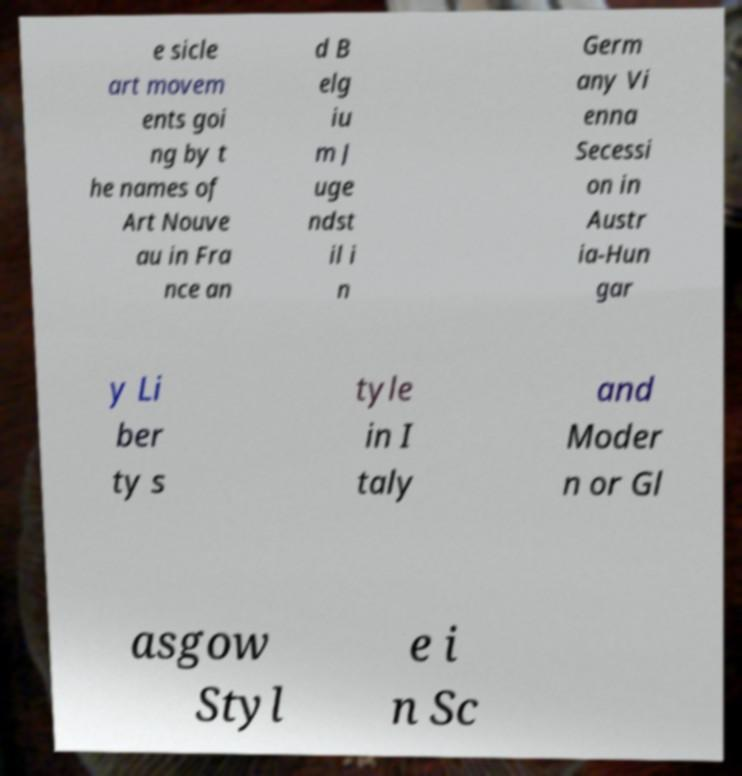Could you extract and type out the text from this image? e sicle art movem ents goi ng by t he names of Art Nouve au in Fra nce an d B elg iu m J uge ndst il i n Germ any Vi enna Secessi on in Austr ia-Hun gar y Li ber ty s tyle in I taly and Moder n or Gl asgow Styl e i n Sc 